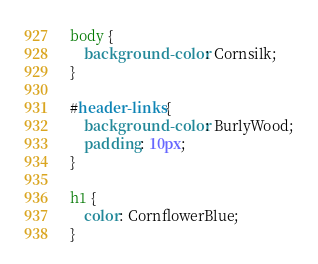Convert code to text. <code><loc_0><loc_0><loc_500><loc_500><_CSS_>body {
    background-color: Cornsilk;
}

#header-links {
    background-color: BurlyWood;
    padding: 10px;
}

h1 {
    color: CornflowerBlue;
}</code> 